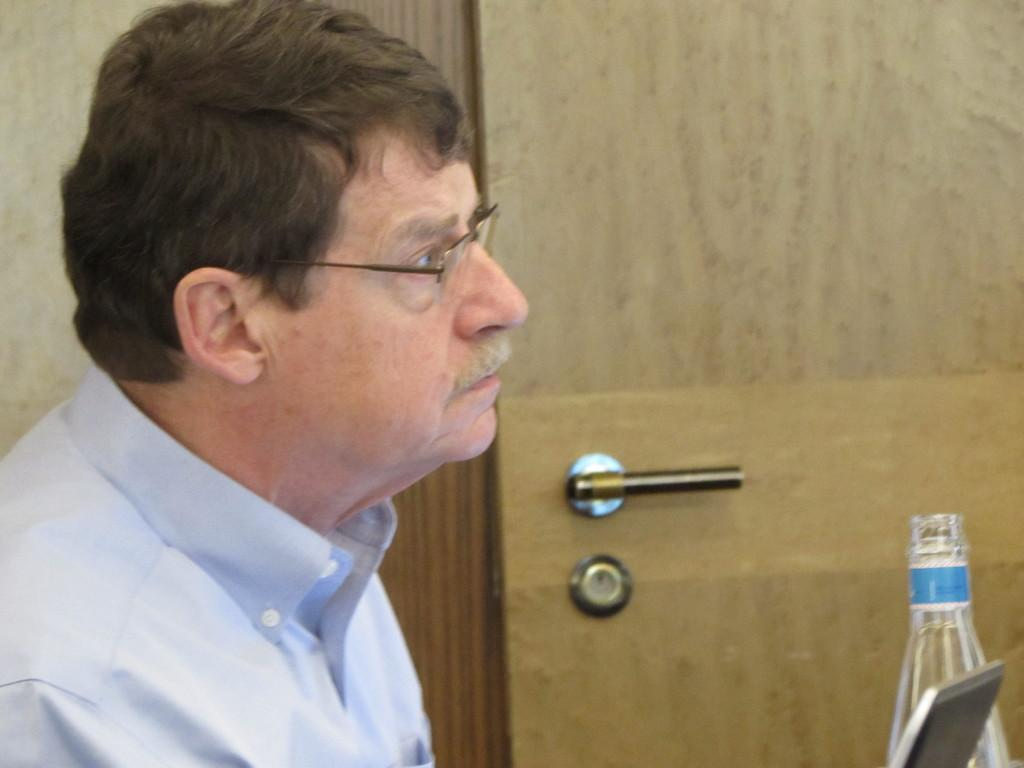What is the main subject of the image? There is a man in the image. What is the man's facial expression in the image? The man is staring at something seriously. What accessory is the man wearing in the image? The man is wearing spectacles. What type of muscle is the man flexing in the image? There is no muscle flexing visible in the image; the man is simply staring seriously. 